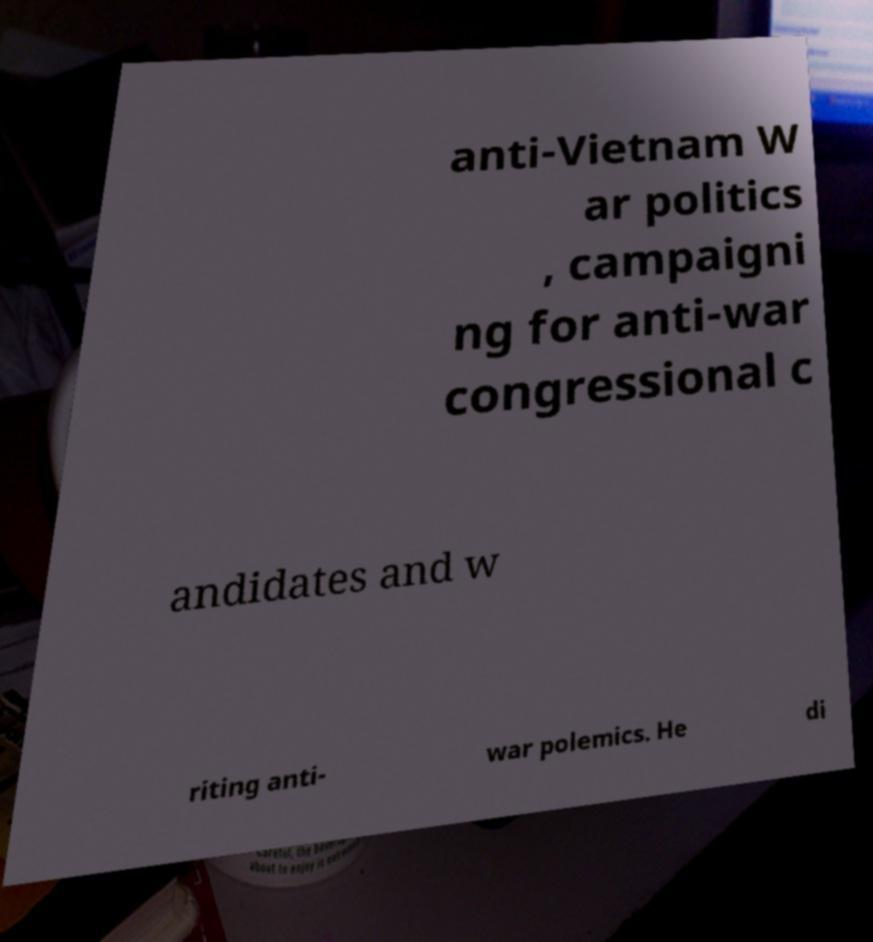Please read and relay the text visible in this image. What does it say? anti-Vietnam W ar politics , campaigni ng for anti-war congressional c andidates and w riting anti- war polemics. He di 